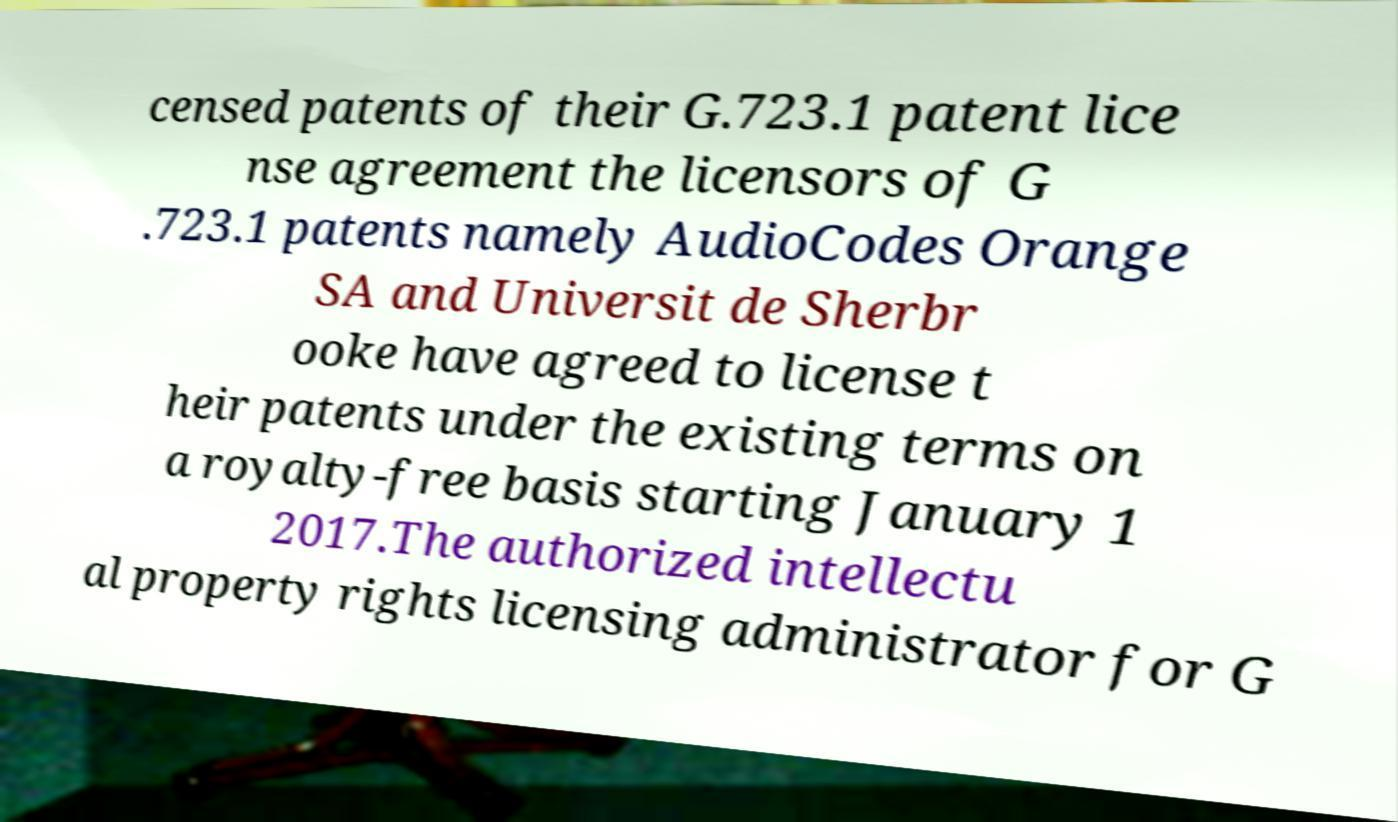Could you assist in decoding the text presented in this image and type it out clearly? censed patents of their G.723.1 patent lice nse agreement the licensors of G .723.1 patents namely AudioCodes Orange SA and Universit de Sherbr ooke have agreed to license t heir patents under the existing terms on a royalty-free basis starting January 1 2017.The authorized intellectu al property rights licensing administrator for G 